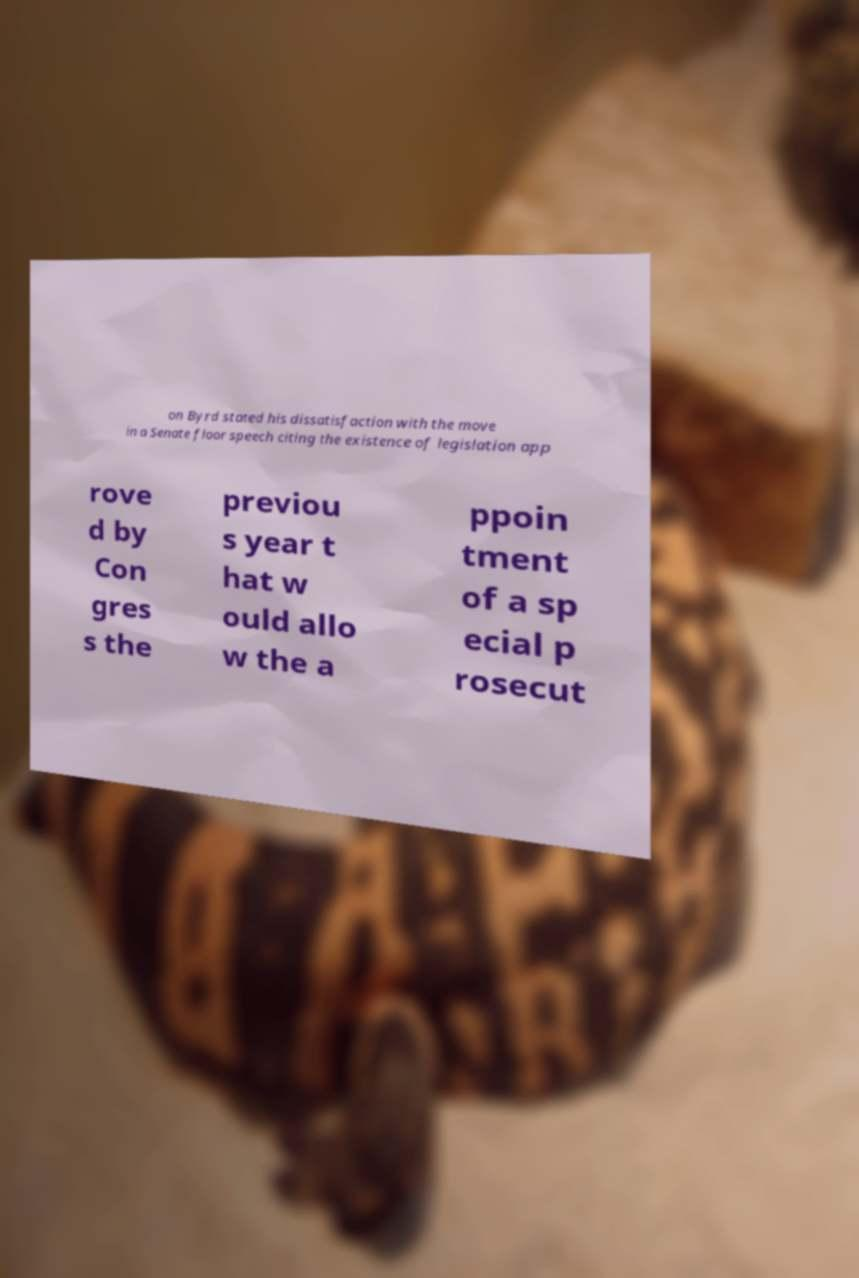Please read and relay the text visible in this image. What does it say? on Byrd stated his dissatisfaction with the move in a Senate floor speech citing the existence of legislation app rove d by Con gres s the previou s year t hat w ould allo w the a ppoin tment of a sp ecial p rosecut 